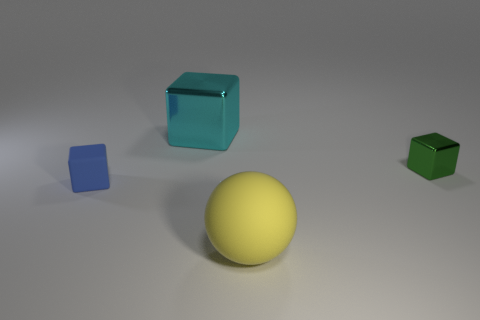Subtract all metal blocks. How many blocks are left? 1 Add 3 large matte balls. How many objects exist? 7 Subtract all green cubes. How many cubes are left? 2 Subtract all cubes. How many objects are left? 1 Subtract 2 cubes. How many cubes are left? 1 Subtract all tiny green shiny spheres. Subtract all matte spheres. How many objects are left? 3 Add 3 blocks. How many blocks are left? 6 Add 3 large yellow rubber spheres. How many large yellow rubber spheres exist? 4 Subtract 0 purple cylinders. How many objects are left? 4 Subtract all gray spheres. Subtract all cyan cylinders. How many spheres are left? 1 